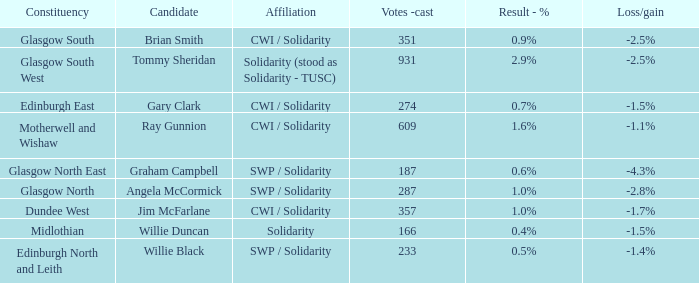How many votes were cast when the constituency was midlothian? 166.0. 